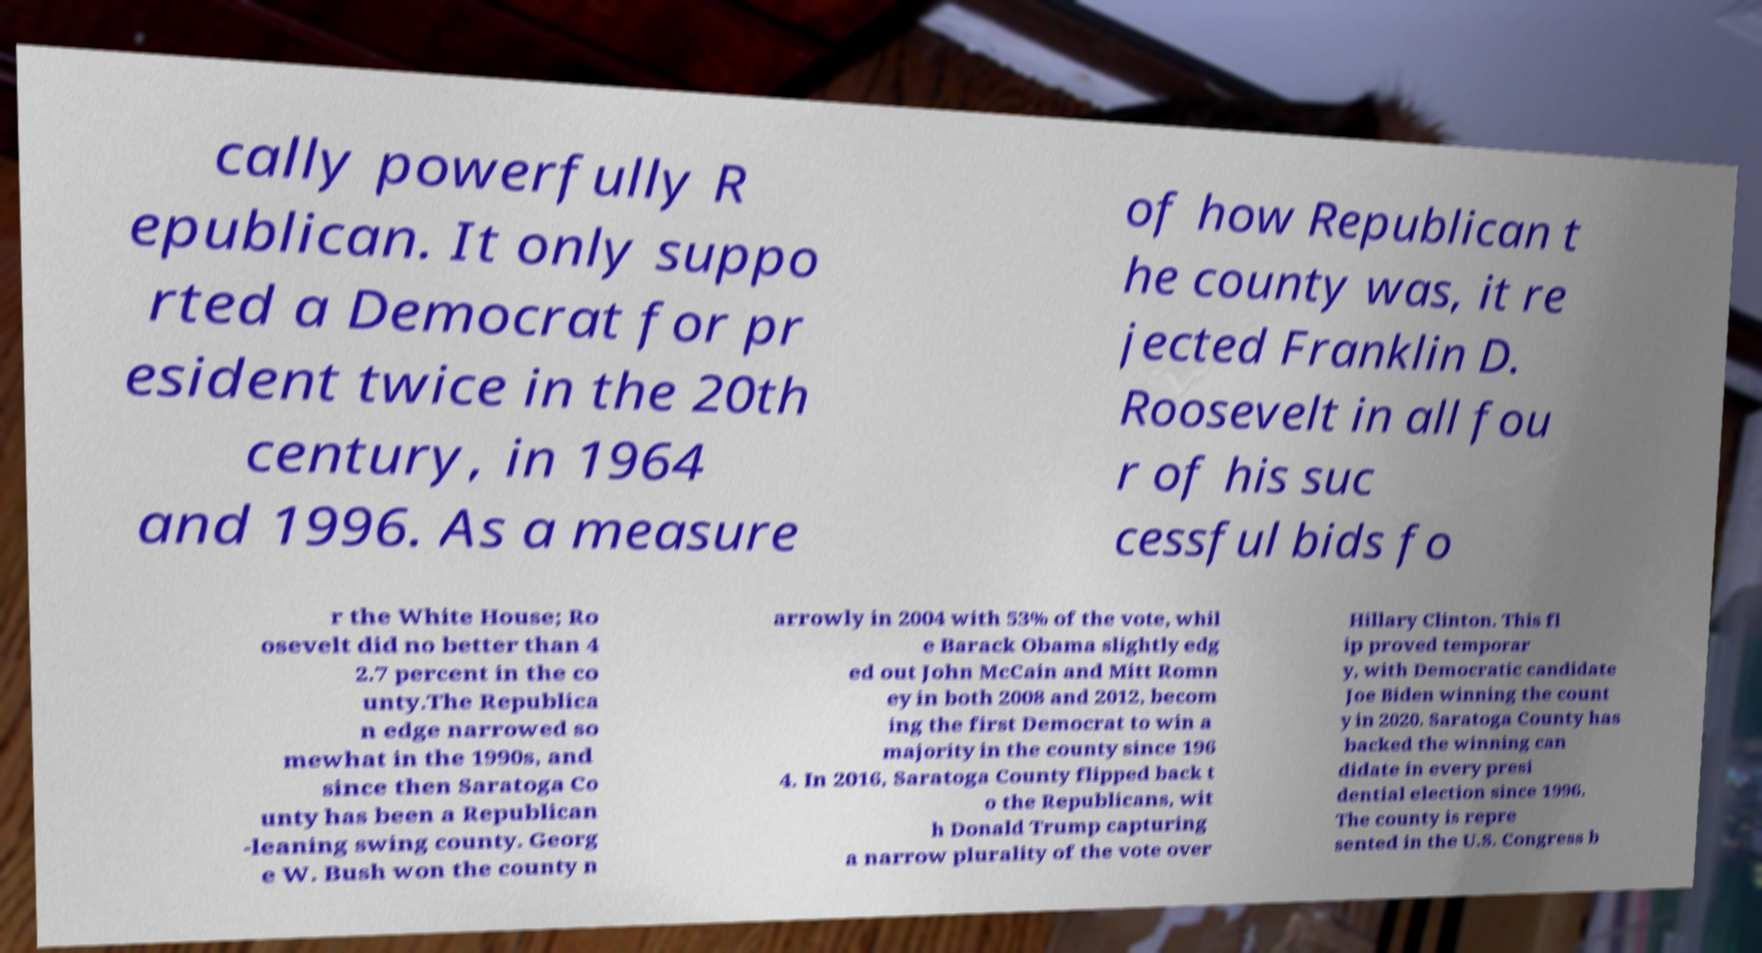Can you accurately transcribe the text from the provided image for me? cally powerfully R epublican. It only suppo rted a Democrat for pr esident twice in the 20th century, in 1964 and 1996. As a measure of how Republican t he county was, it re jected Franklin D. Roosevelt in all fou r of his suc cessful bids fo r the White House; Ro osevelt did no better than 4 2.7 percent in the co unty.The Republica n edge narrowed so mewhat in the 1990s, and since then Saratoga Co unty has been a Republican -leaning swing county. Georg e W. Bush won the county n arrowly in 2004 with 53% of the vote, whil e Barack Obama slightly edg ed out John McCain and Mitt Romn ey in both 2008 and 2012, becom ing the first Democrat to win a majority in the county since 196 4. In 2016, Saratoga County flipped back t o the Republicans, wit h Donald Trump capturing a narrow plurality of the vote over Hillary Clinton. This fl ip proved temporar y, with Democratic candidate Joe Biden winning the count y in 2020. Saratoga County has backed the winning can didate in every presi dential election since 1996. The county is repre sented in the U.S. Congress b 